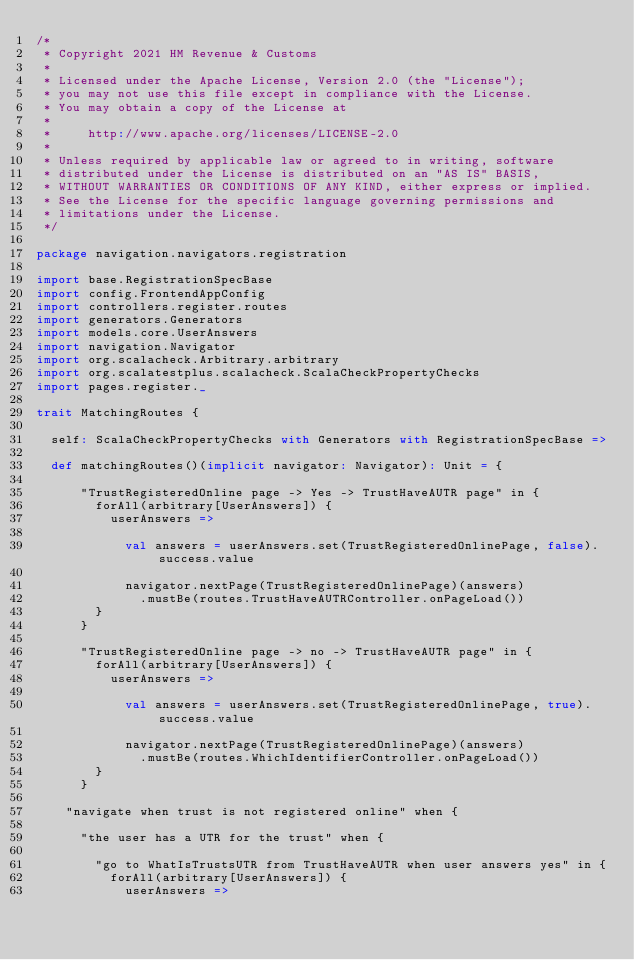Convert code to text. <code><loc_0><loc_0><loc_500><loc_500><_Scala_>/*
 * Copyright 2021 HM Revenue & Customs
 *
 * Licensed under the Apache License, Version 2.0 (the "License");
 * you may not use this file except in compliance with the License.
 * You may obtain a copy of the License at
 *
 *     http://www.apache.org/licenses/LICENSE-2.0
 *
 * Unless required by applicable law or agreed to in writing, software
 * distributed under the License is distributed on an "AS IS" BASIS,
 * WITHOUT WARRANTIES OR CONDITIONS OF ANY KIND, either express or implied.
 * See the License for the specific language governing permissions and
 * limitations under the License.
 */

package navigation.navigators.registration

import base.RegistrationSpecBase
import config.FrontendAppConfig
import controllers.register.routes
import generators.Generators
import models.core.UserAnswers
import navigation.Navigator
import org.scalacheck.Arbitrary.arbitrary
import org.scalatestplus.scalacheck.ScalaCheckPropertyChecks
import pages.register._

trait MatchingRoutes {

  self: ScalaCheckPropertyChecks with Generators with RegistrationSpecBase =>

  def matchingRoutes()(implicit navigator: Navigator): Unit = {

      "TrustRegisteredOnline page -> Yes -> TrustHaveAUTR page" in {
        forAll(arbitrary[UserAnswers]) {
          userAnswers =>

            val answers = userAnswers.set(TrustRegisteredOnlinePage, false).success.value

            navigator.nextPage(TrustRegisteredOnlinePage)(answers)
              .mustBe(routes.TrustHaveAUTRController.onPageLoad())
        }
      }

      "TrustRegisteredOnline page -> no -> TrustHaveAUTR page" in {
        forAll(arbitrary[UserAnswers]) {
          userAnswers =>

            val answers = userAnswers.set(TrustRegisteredOnlinePage, true).success.value

            navigator.nextPage(TrustRegisteredOnlinePage)(answers)
              .mustBe(routes.WhichIdentifierController.onPageLoad())
        }
      }

    "navigate when trust is not registered online" when {

      "the user has a UTR for the trust" when {

        "go to WhatIsTrustsUTR from TrustHaveAUTR when user answers yes" in {
          forAll(arbitrary[UserAnswers]) {
            userAnswers =>
</code> 